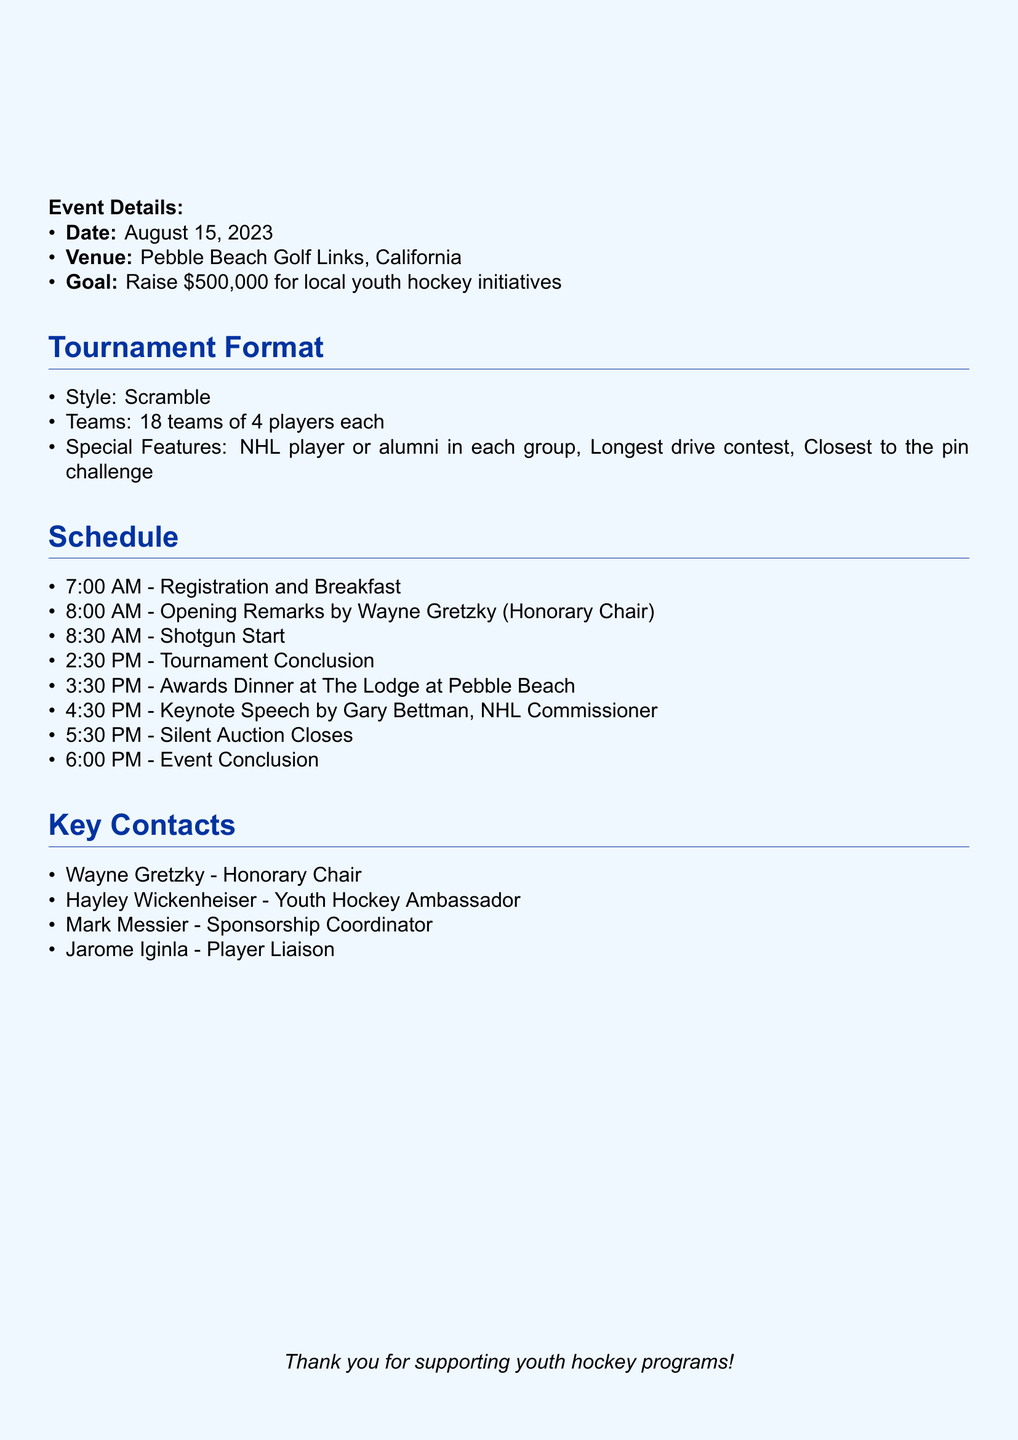What is the event title? The title is clearly mentioned in the document under the event overview section.
Answer: Ice to Green: Charity Golf Tournament for Youth Hockey Programs What is the date of the tournament? The date is specified early in the event overview section.
Answer: August 15, 2023 Who is the Honorary Chair of the event? The document specifies Wayne Gretzky as the Honorary Chair in the planning committee section.
Answer: Wayne Gretzky What is the goal fundraising amount? The fundraising goal is mentioned in the event overview section.
Answer: $500,000 How many teams will be participating? The document specifies the number of teams in the tournament format section.
Answer: 18 teams What is the entry fee per team? The entry fee is outlined in the financial considerations section of the document.
Answer: $5,000 per team Which item is included in the silent auction? The document lists specific items included in the silent auction under the financial considerations section.
Answer: Signed Sidney Crosby jersey Who is speaking at the awards dinner? The speaker at the awards dinner is indicated in the post-event activities section.
Answer: Gary Bettman, NHL Commissioner What type of golf format is being used? The tournament format specifies the style of play, which is mentioned in that section.
Answer: Scramble 